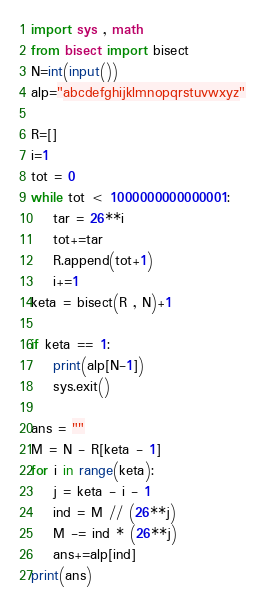Convert code to text. <code><loc_0><loc_0><loc_500><loc_500><_Python_>import sys , math
from bisect import bisect
N=int(input())
alp="abcdefghijklmnopqrstuvwxyz"

R=[]
i=1
tot = 0
while tot < 1000000000000001:
    tar = 26**i
    tot+=tar
    R.append(tot+1)
    i+=1
keta = bisect(R , N)+1

if keta == 1:
    print(alp[N-1])
    sys.exit()

ans = ""
M = N - R[keta - 1]
for i in range(keta):
    j = keta - i - 1
    ind = M // (26**j)
    M -= ind * (26**j)
    ans+=alp[ind]
print(ans)</code> 